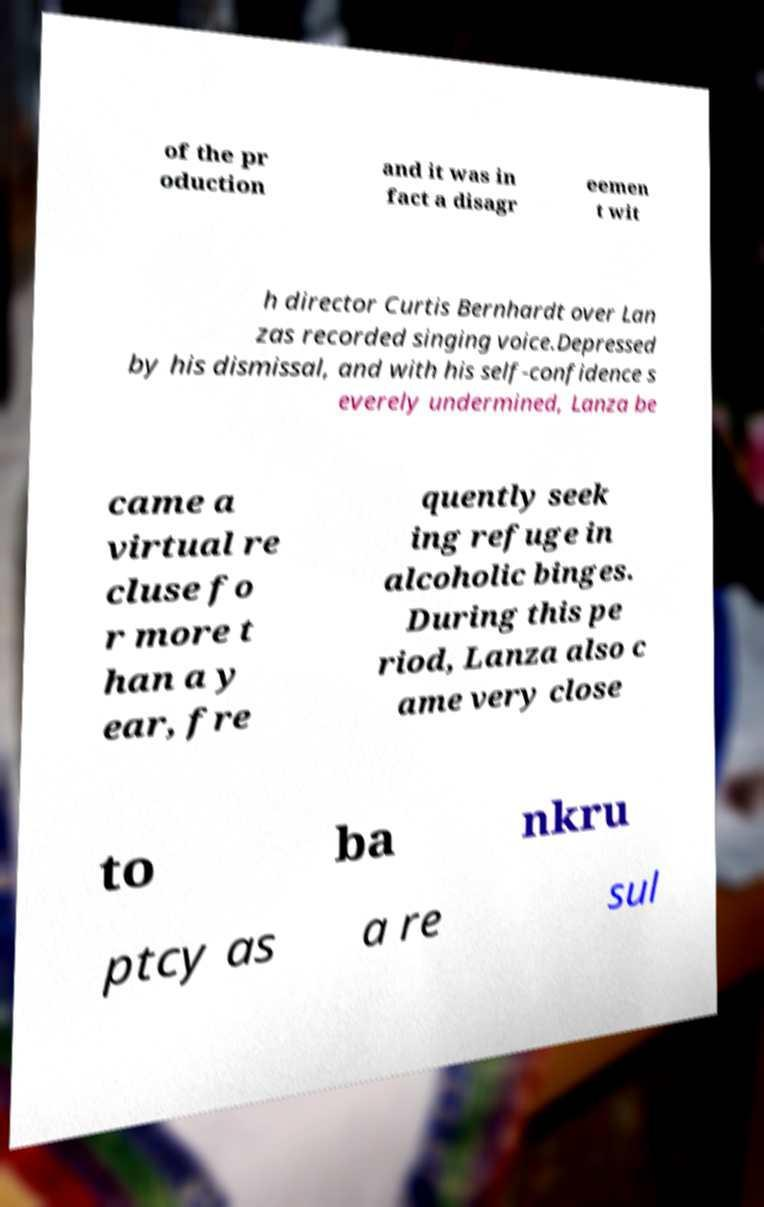What messages or text are displayed in this image? I need them in a readable, typed format. of the pr oduction and it was in fact a disagr eemen t wit h director Curtis Bernhardt over Lan zas recorded singing voice.Depressed by his dismissal, and with his self-confidence s everely undermined, Lanza be came a virtual re cluse fo r more t han a y ear, fre quently seek ing refuge in alcoholic binges. During this pe riod, Lanza also c ame very close to ba nkru ptcy as a re sul 